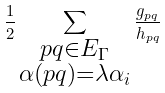<formula> <loc_0><loc_0><loc_500><loc_500>\frac { 1 } { 2 } \sum _ { \substack { p q \in E _ { \Gamma } \\ \alpha ( p q ) = \lambda \alpha _ { i } \\ } } \frac { g _ { p q } } { h _ { p q } }</formula> 